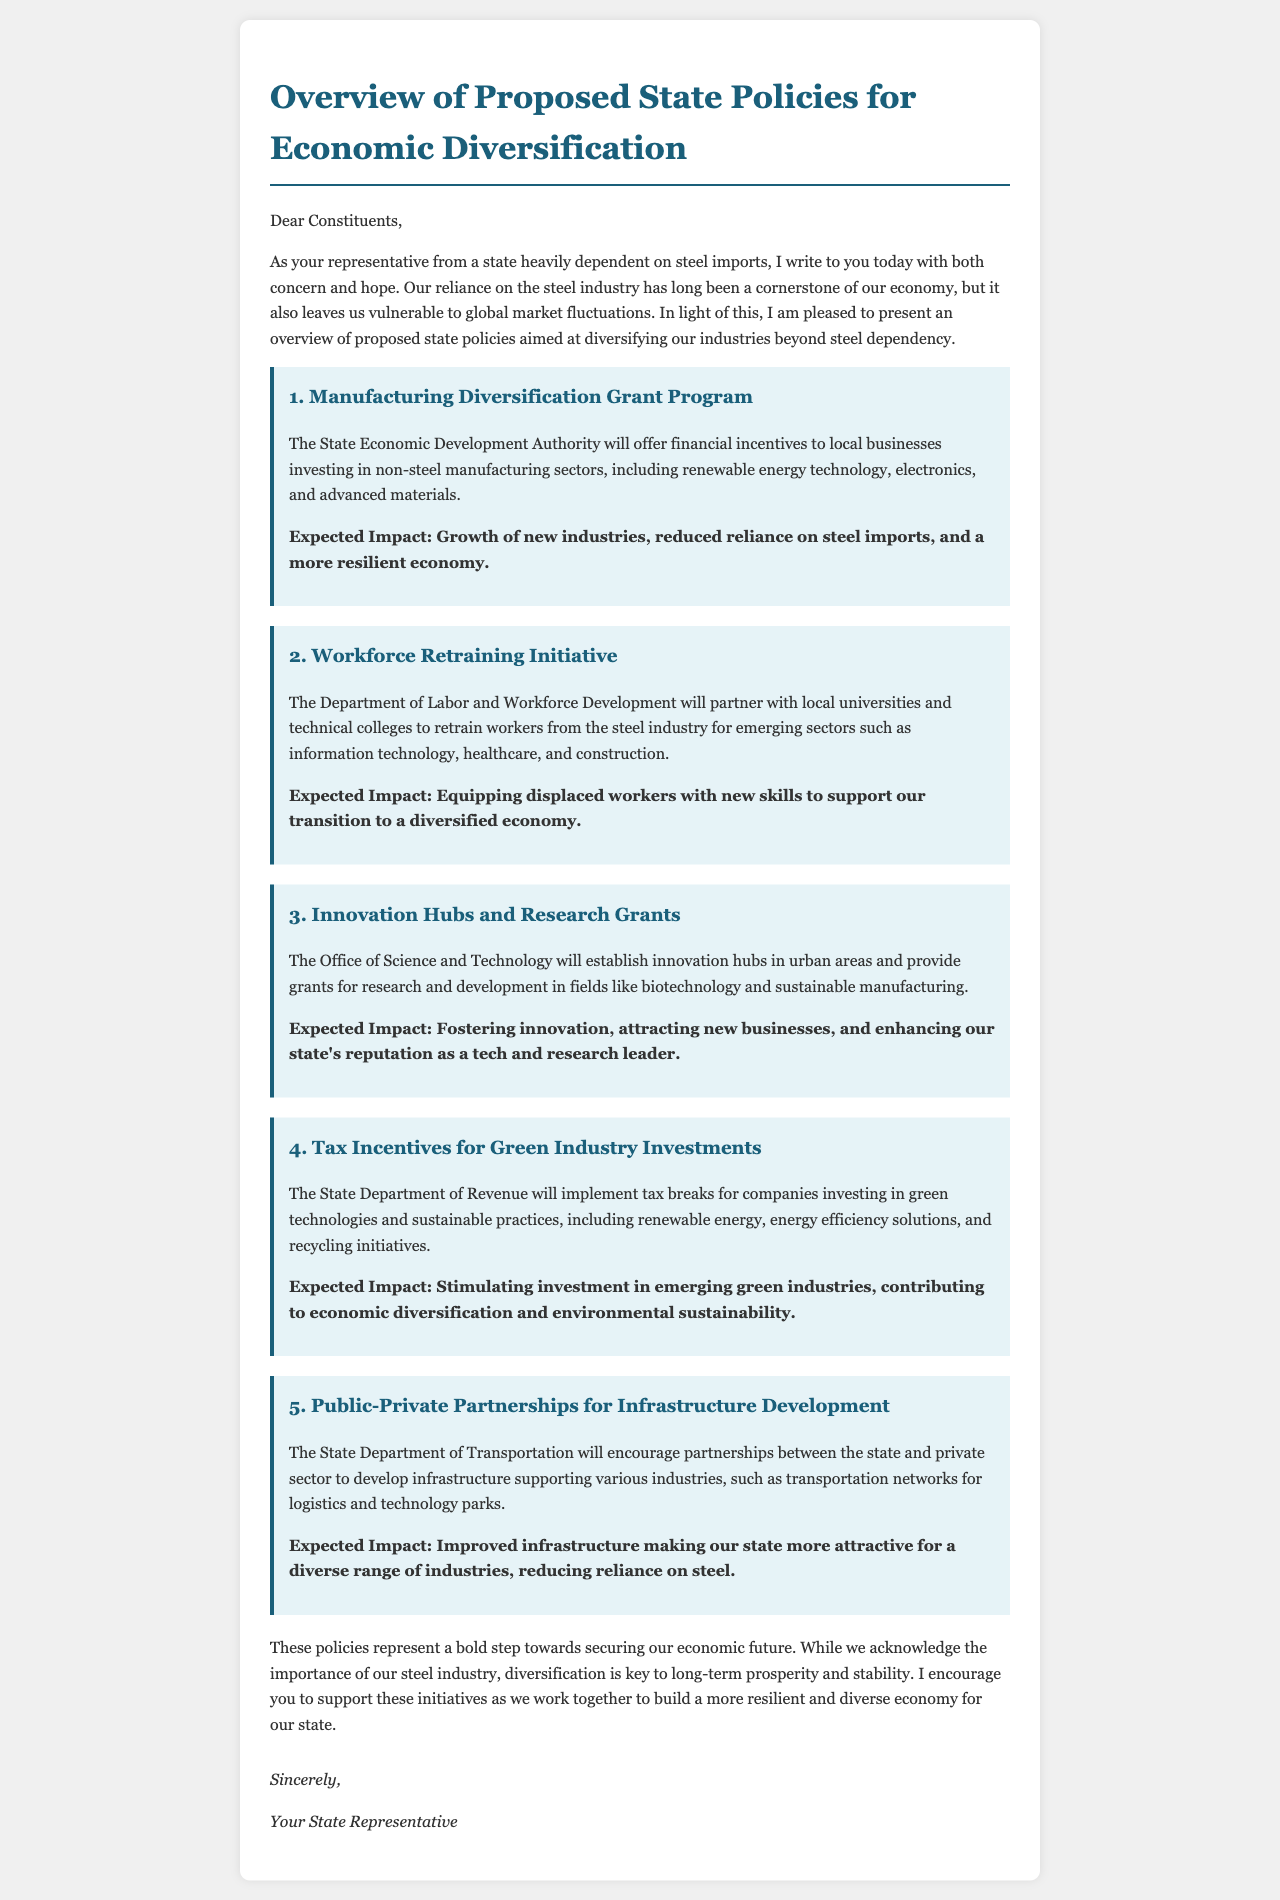What is the title of the letter? The title of the letter clearly states the subject it addresses, which is an overview of state policies.
Answer: Overview of Proposed State Policies for Economic Diversification Who is the letter addressed to? The introductory paragraph indicates that the letter is directed towards a specific audience, namely the constituents of the representative.
Answer: Dear Constituents Which department will offer financial incentives to local businesses? The document specifies the name of the authority responsible for the manufacturing diversification grant program.
Answer: State Economic Development Authority How many proposed policies are outlined in the letter? Counting the number of distinct policy sections in the document provides the total proposed policies.
Answer: 5 What is the expected impact of the Workforce Retraining Initiative? The impact is defined within the section regarding the initiative, summarizing its goals for workers.
Answer: Equipping displaced workers with new skills to support our transition to a diversified economy What type of partnerships does the fifth policy promote? The document specifies the nature of partnerships that the state department encourages for infrastructure development.
Answer: Public-Private Partnerships What industry is the first policy aimed at diversifying? The content of the first policy specifies the sectors that the program is focusing on, allowing for nature identification.
Answer: Non-steel manufacturing sectors What is the main goal of the tax incentives in policy four? The document articulates how the tax incentives are intended to impact investments and industries within the state.
Answer: Stimulating investment in emerging green industries What organization will establish innovation hubs? The document mentions the office responsible for the innovation hubs in the state.
Answer: Office of Science and Technology 